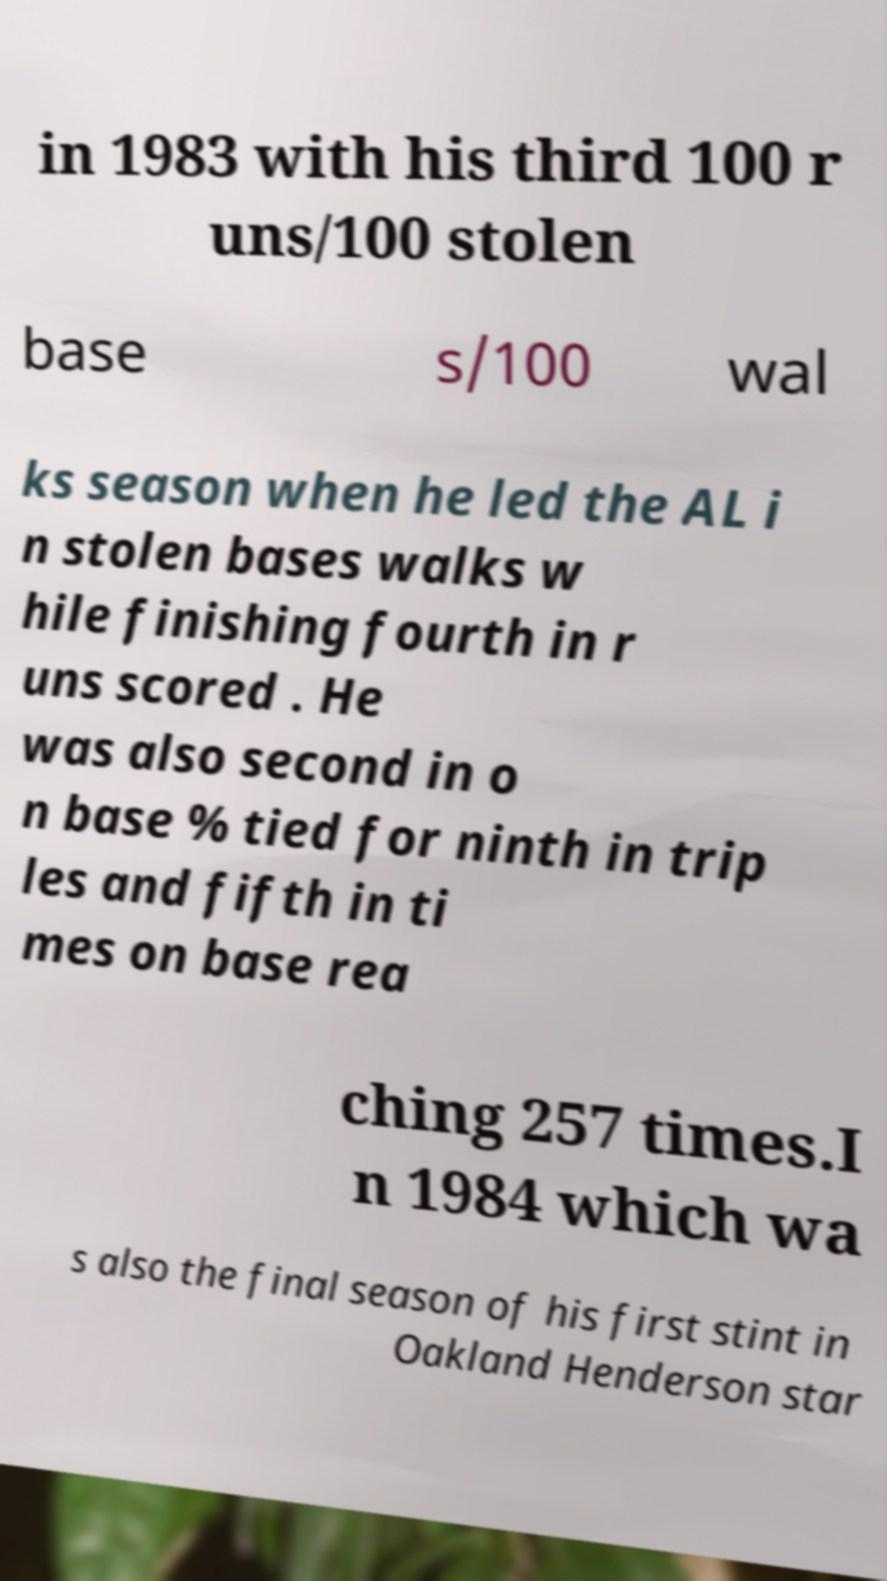Please read and relay the text visible in this image. What does it say? in 1983 with his third 100 r uns/100 stolen base s/100 wal ks season when he led the AL i n stolen bases walks w hile finishing fourth in r uns scored . He was also second in o n base % tied for ninth in trip les and fifth in ti mes on base rea ching 257 times.I n 1984 which wa s also the final season of his first stint in Oakland Henderson star 